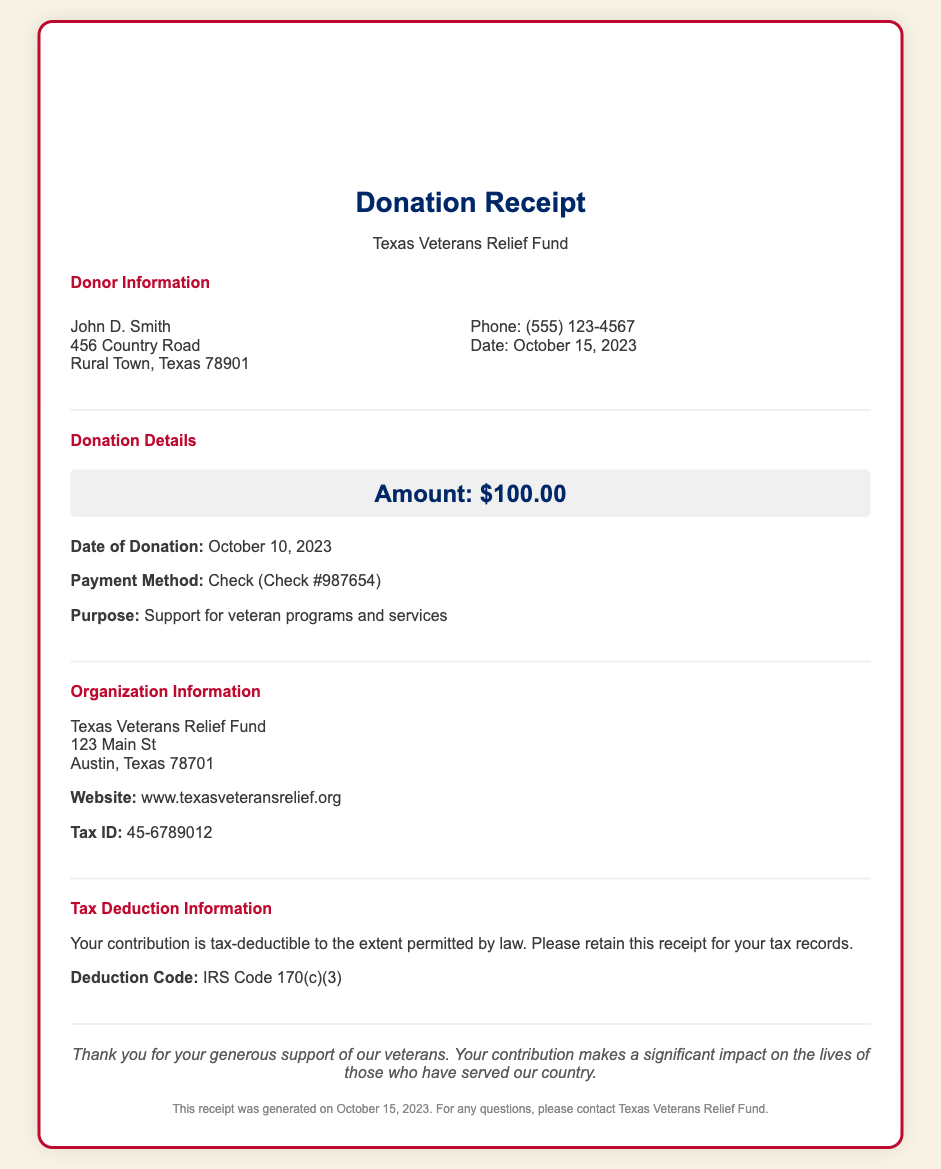what is the name of the donor? The donor's name is mentioned in the Donor Information section of the document.
Answer: John D. Smith what was the donation amount? The donation amount is clearly specified in the Donation Details section of the document.
Answer: $100.00 when was the donation made? The date of the donation is provided in the Donation Details section of the document.
Answer: October 10, 2023 what is the purpose of the donation? The purpose of the donation is explained in the Donation Details section.
Answer: Support for veteran programs and services what is the Tax ID of the organization? The Tax ID is listed in the Organization Information section of the document.
Answer: 45-6789012 what is the deduction code for the donation? The deduction code is provided in the Tax Deduction Information section.
Answer: IRS Code 170(c)(3) what is the organization’s website? The website of the organization is stated in the Organization Information section.
Answer: www.texasveteransrelief.org how should the donor retain the receipt? The document advises on how to manage the receipt for tax purposes.
Answer: For tax records 